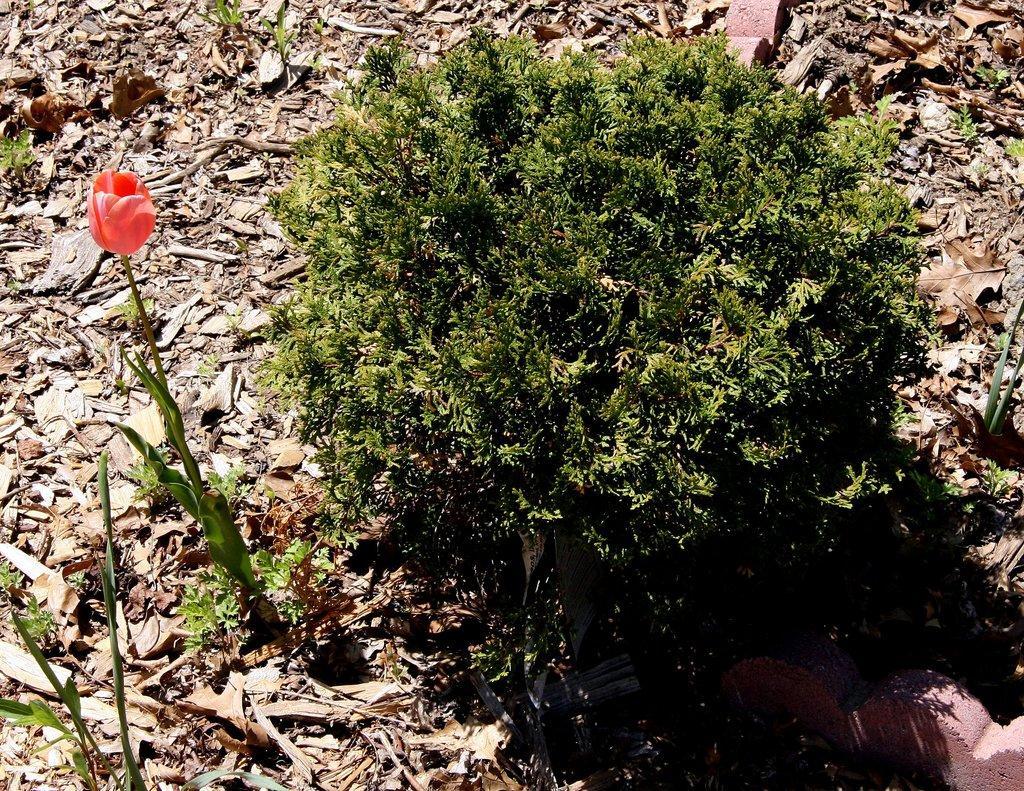Describe this image in one or two sentences. In the image there is a flower plant and beside that there is another plant and around the plants there are many dry leaves. 